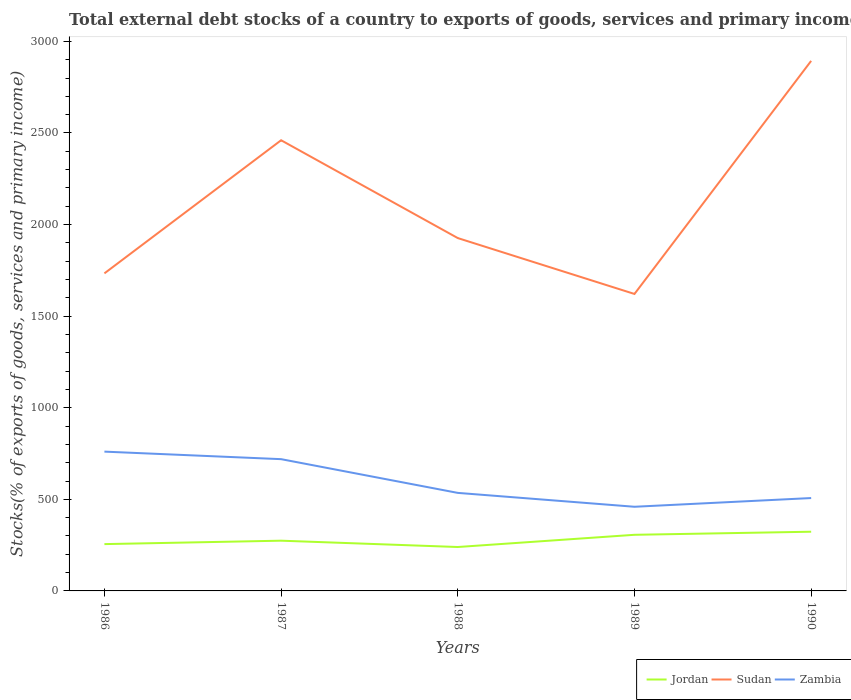Does the line corresponding to Zambia intersect with the line corresponding to Sudan?
Offer a very short reply. No. Is the number of lines equal to the number of legend labels?
Offer a very short reply. Yes. Across all years, what is the maximum total debt stocks in Sudan?
Make the answer very short. 1621.22. In which year was the total debt stocks in Zambia maximum?
Your answer should be very brief. 1989. What is the total total debt stocks in Zambia in the graph?
Your answer should be very brief. 41.12. What is the difference between the highest and the second highest total debt stocks in Zambia?
Your answer should be compact. 301.03. How many lines are there?
Your response must be concise. 3. What is the difference between two consecutive major ticks on the Y-axis?
Provide a short and direct response. 500. Are the values on the major ticks of Y-axis written in scientific E-notation?
Your response must be concise. No. Does the graph contain any zero values?
Offer a terse response. No. Does the graph contain grids?
Your answer should be very brief. No. How many legend labels are there?
Your answer should be very brief. 3. How are the legend labels stacked?
Offer a very short reply. Horizontal. What is the title of the graph?
Ensure brevity in your answer.  Total external debt stocks of a country to exports of goods, services and primary income. Does "Cayman Islands" appear as one of the legend labels in the graph?
Ensure brevity in your answer.  No. What is the label or title of the X-axis?
Ensure brevity in your answer.  Years. What is the label or title of the Y-axis?
Your answer should be very brief. Stocks(% of exports of goods, services and primary income). What is the Stocks(% of exports of goods, services and primary income) in Jordan in 1986?
Provide a short and direct response. 255.52. What is the Stocks(% of exports of goods, services and primary income) of Sudan in 1986?
Give a very brief answer. 1733.61. What is the Stocks(% of exports of goods, services and primary income) of Zambia in 1986?
Ensure brevity in your answer.  760.44. What is the Stocks(% of exports of goods, services and primary income) of Jordan in 1987?
Provide a succinct answer. 274.26. What is the Stocks(% of exports of goods, services and primary income) in Sudan in 1987?
Make the answer very short. 2460.33. What is the Stocks(% of exports of goods, services and primary income) of Zambia in 1987?
Offer a very short reply. 719.32. What is the Stocks(% of exports of goods, services and primary income) of Jordan in 1988?
Offer a terse response. 239.73. What is the Stocks(% of exports of goods, services and primary income) of Sudan in 1988?
Provide a succinct answer. 1926.25. What is the Stocks(% of exports of goods, services and primary income) of Zambia in 1988?
Make the answer very short. 535.19. What is the Stocks(% of exports of goods, services and primary income) in Jordan in 1989?
Give a very brief answer. 306.42. What is the Stocks(% of exports of goods, services and primary income) in Sudan in 1989?
Offer a very short reply. 1621.22. What is the Stocks(% of exports of goods, services and primary income) of Zambia in 1989?
Your answer should be compact. 459.41. What is the Stocks(% of exports of goods, services and primary income) of Jordan in 1990?
Keep it short and to the point. 323.17. What is the Stocks(% of exports of goods, services and primary income) in Sudan in 1990?
Ensure brevity in your answer.  2893.63. What is the Stocks(% of exports of goods, services and primary income) of Zambia in 1990?
Ensure brevity in your answer.  507. Across all years, what is the maximum Stocks(% of exports of goods, services and primary income) of Jordan?
Your answer should be compact. 323.17. Across all years, what is the maximum Stocks(% of exports of goods, services and primary income) of Sudan?
Your answer should be very brief. 2893.63. Across all years, what is the maximum Stocks(% of exports of goods, services and primary income) of Zambia?
Provide a succinct answer. 760.44. Across all years, what is the minimum Stocks(% of exports of goods, services and primary income) in Jordan?
Offer a terse response. 239.73. Across all years, what is the minimum Stocks(% of exports of goods, services and primary income) of Sudan?
Provide a succinct answer. 1621.22. Across all years, what is the minimum Stocks(% of exports of goods, services and primary income) in Zambia?
Your answer should be very brief. 459.41. What is the total Stocks(% of exports of goods, services and primary income) in Jordan in the graph?
Make the answer very short. 1399.09. What is the total Stocks(% of exports of goods, services and primary income) in Sudan in the graph?
Ensure brevity in your answer.  1.06e+04. What is the total Stocks(% of exports of goods, services and primary income) in Zambia in the graph?
Offer a very short reply. 2981.35. What is the difference between the Stocks(% of exports of goods, services and primary income) of Jordan in 1986 and that in 1987?
Ensure brevity in your answer.  -18.74. What is the difference between the Stocks(% of exports of goods, services and primary income) of Sudan in 1986 and that in 1987?
Provide a short and direct response. -726.73. What is the difference between the Stocks(% of exports of goods, services and primary income) in Zambia in 1986 and that in 1987?
Keep it short and to the point. 41.12. What is the difference between the Stocks(% of exports of goods, services and primary income) in Jordan in 1986 and that in 1988?
Offer a terse response. 15.79. What is the difference between the Stocks(% of exports of goods, services and primary income) in Sudan in 1986 and that in 1988?
Give a very brief answer. -192.65. What is the difference between the Stocks(% of exports of goods, services and primary income) of Zambia in 1986 and that in 1988?
Offer a very short reply. 225.25. What is the difference between the Stocks(% of exports of goods, services and primary income) of Jordan in 1986 and that in 1989?
Offer a very short reply. -50.9. What is the difference between the Stocks(% of exports of goods, services and primary income) in Sudan in 1986 and that in 1989?
Provide a short and direct response. 112.39. What is the difference between the Stocks(% of exports of goods, services and primary income) of Zambia in 1986 and that in 1989?
Make the answer very short. 301.03. What is the difference between the Stocks(% of exports of goods, services and primary income) in Jordan in 1986 and that in 1990?
Provide a succinct answer. -67.65. What is the difference between the Stocks(% of exports of goods, services and primary income) of Sudan in 1986 and that in 1990?
Your answer should be compact. -1160.03. What is the difference between the Stocks(% of exports of goods, services and primary income) of Zambia in 1986 and that in 1990?
Offer a terse response. 253.44. What is the difference between the Stocks(% of exports of goods, services and primary income) in Jordan in 1987 and that in 1988?
Make the answer very short. 34.53. What is the difference between the Stocks(% of exports of goods, services and primary income) in Sudan in 1987 and that in 1988?
Keep it short and to the point. 534.08. What is the difference between the Stocks(% of exports of goods, services and primary income) in Zambia in 1987 and that in 1988?
Make the answer very short. 184.13. What is the difference between the Stocks(% of exports of goods, services and primary income) in Jordan in 1987 and that in 1989?
Ensure brevity in your answer.  -32.16. What is the difference between the Stocks(% of exports of goods, services and primary income) in Sudan in 1987 and that in 1989?
Keep it short and to the point. 839.11. What is the difference between the Stocks(% of exports of goods, services and primary income) of Zambia in 1987 and that in 1989?
Your answer should be very brief. 259.91. What is the difference between the Stocks(% of exports of goods, services and primary income) of Jordan in 1987 and that in 1990?
Provide a short and direct response. -48.91. What is the difference between the Stocks(% of exports of goods, services and primary income) of Sudan in 1987 and that in 1990?
Offer a terse response. -433.3. What is the difference between the Stocks(% of exports of goods, services and primary income) in Zambia in 1987 and that in 1990?
Your answer should be very brief. 212.32. What is the difference between the Stocks(% of exports of goods, services and primary income) in Jordan in 1988 and that in 1989?
Your answer should be compact. -66.69. What is the difference between the Stocks(% of exports of goods, services and primary income) of Sudan in 1988 and that in 1989?
Offer a terse response. 305.04. What is the difference between the Stocks(% of exports of goods, services and primary income) in Zambia in 1988 and that in 1989?
Make the answer very short. 75.78. What is the difference between the Stocks(% of exports of goods, services and primary income) of Jordan in 1988 and that in 1990?
Keep it short and to the point. -83.44. What is the difference between the Stocks(% of exports of goods, services and primary income) in Sudan in 1988 and that in 1990?
Your answer should be compact. -967.38. What is the difference between the Stocks(% of exports of goods, services and primary income) in Zambia in 1988 and that in 1990?
Ensure brevity in your answer.  28.19. What is the difference between the Stocks(% of exports of goods, services and primary income) of Jordan in 1989 and that in 1990?
Provide a succinct answer. -16.75. What is the difference between the Stocks(% of exports of goods, services and primary income) in Sudan in 1989 and that in 1990?
Make the answer very short. -1272.42. What is the difference between the Stocks(% of exports of goods, services and primary income) of Zambia in 1989 and that in 1990?
Offer a terse response. -47.59. What is the difference between the Stocks(% of exports of goods, services and primary income) of Jordan in 1986 and the Stocks(% of exports of goods, services and primary income) of Sudan in 1987?
Give a very brief answer. -2204.81. What is the difference between the Stocks(% of exports of goods, services and primary income) of Jordan in 1986 and the Stocks(% of exports of goods, services and primary income) of Zambia in 1987?
Offer a terse response. -463.8. What is the difference between the Stocks(% of exports of goods, services and primary income) of Sudan in 1986 and the Stocks(% of exports of goods, services and primary income) of Zambia in 1987?
Offer a very short reply. 1014.29. What is the difference between the Stocks(% of exports of goods, services and primary income) of Jordan in 1986 and the Stocks(% of exports of goods, services and primary income) of Sudan in 1988?
Offer a terse response. -1670.73. What is the difference between the Stocks(% of exports of goods, services and primary income) of Jordan in 1986 and the Stocks(% of exports of goods, services and primary income) of Zambia in 1988?
Provide a succinct answer. -279.67. What is the difference between the Stocks(% of exports of goods, services and primary income) in Sudan in 1986 and the Stocks(% of exports of goods, services and primary income) in Zambia in 1988?
Your response must be concise. 1198.42. What is the difference between the Stocks(% of exports of goods, services and primary income) in Jordan in 1986 and the Stocks(% of exports of goods, services and primary income) in Sudan in 1989?
Make the answer very short. -1365.7. What is the difference between the Stocks(% of exports of goods, services and primary income) of Jordan in 1986 and the Stocks(% of exports of goods, services and primary income) of Zambia in 1989?
Keep it short and to the point. -203.89. What is the difference between the Stocks(% of exports of goods, services and primary income) of Sudan in 1986 and the Stocks(% of exports of goods, services and primary income) of Zambia in 1989?
Provide a succinct answer. 1274.2. What is the difference between the Stocks(% of exports of goods, services and primary income) in Jordan in 1986 and the Stocks(% of exports of goods, services and primary income) in Sudan in 1990?
Keep it short and to the point. -2638.12. What is the difference between the Stocks(% of exports of goods, services and primary income) of Jordan in 1986 and the Stocks(% of exports of goods, services and primary income) of Zambia in 1990?
Offer a very short reply. -251.48. What is the difference between the Stocks(% of exports of goods, services and primary income) in Sudan in 1986 and the Stocks(% of exports of goods, services and primary income) in Zambia in 1990?
Give a very brief answer. 1226.61. What is the difference between the Stocks(% of exports of goods, services and primary income) in Jordan in 1987 and the Stocks(% of exports of goods, services and primary income) in Sudan in 1988?
Your response must be concise. -1652. What is the difference between the Stocks(% of exports of goods, services and primary income) of Jordan in 1987 and the Stocks(% of exports of goods, services and primary income) of Zambia in 1988?
Give a very brief answer. -260.93. What is the difference between the Stocks(% of exports of goods, services and primary income) of Sudan in 1987 and the Stocks(% of exports of goods, services and primary income) of Zambia in 1988?
Offer a terse response. 1925.14. What is the difference between the Stocks(% of exports of goods, services and primary income) in Jordan in 1987 and the Stocks(% of exports of goods, services and primary income) in Sudan in 1989?
Your response must be concise. -1346.96. What is the difference between the Stocks(% of exports of goods, services and primary income) in Jordan in 1987 and the Stocks(% of exports of goods, services and primary income) in Zambia in 1989?
Offer a very short reply. -185.15. What is the difference between the Stocks(% of exports of goods, services and primary income) in Sudan in 1987 and the Stocks(% of exports of goods, services and primary income) in Zambia in 1989?
Give a very brief answer. 2000.92. What is the difference between the Stocks(% of exports of goods, services and primary income) in Jordan in 1987 and the Stocks(% of exports of goods, services and primary income) in Sudan in 1990?
Ensure brevity in your answer.  -2619.38. What is the difference between the Stocks(% of exports of goods, services and primary income) of Jordan in 1987 and the Stocks(% of exports of goods, services and primary income) of Zambia in 1990?
Offer a terse response. -232.74. What is the difference between the Stocks(% of exports of goods, services and primary income) of Sudan in 1987 and the Stocks(% of exports of goods, services and primary income) of Zambia in 1990?
Provide a short and direct response. 1953.33. What is the difference between the Stocks(% of exports of goods, services and primary income) in Jordan in 1988 and the Stocks(% of exports of goods, services and primary income) in Sudan in 1989?
Ensure brevity in your answer.  -1381.49. What is the difference between the Stocks(% of exports of goods, services and primary income) of Jordan in 1988 and the Stocks(% of exports of goods, services and primary income) of Zambia in 1989?
Make the answer very short. -219.68. What is the difference between the Stocks(% of exports of goods, services and primary income) of Sudan in 1988 and the Stocks(% of exports of goods, services and primary income) of Zambia in 1989?
Ensure brevity in your answer.  1466.85. What is the difference between the Stocks(% of exports of goods, services and primary income) of Jordan in 1988 and the Stocks(% of exports of goods, services and primary income) of Sudan in 1990?
Offer a terse response. -2653.9. What is the difference between the Stocks(% of exports of goods, services and primary income) of Jordan in 1988 and the Stocks(% of exports of goods, services and primary income) of Zambia in 1990?
Your answer should be compact. -267.27. What is the difference between the Stocks(% of exports of goods, services and primary income) of Sudan in 1988 and the Stocks(% of exports of goods, services and primary income) of Zambia in 1990?
Provide a succinct answer. 1419.25. What is the difference between the Stocks(% of exports of goods, services and primary income) in Jordan in 1989 and the Stocks(% of exports of goods, services and primary income) in Sudan in 1990?
Keep it short and to the point. -2587.22. What is the difference between the Stocks(% of exports of goods, services and primary income) of Jordan in 1989 and the Stocks(% of exports of goods, services and primary income) of Zambia in 1990?
Your answer should be compact. -200.58. What is the difference between the Stocks(% of exports of goods, services and primary income) in Sudan in 1989 and the Stocks(% of exports of goods, services and primary income) in Zambia in 1990?
Keep it short and to the point. 1114.22. What is the average Stocks(% of exports of goods, services and primary income) in Jordan per year?
Your answer should be compact. 279.82. What is the average Stocks(% of exports of goods, services and primary income) of Sudan per year?
Your answer should be compact. 2127.01. What is the average Stocks(% of exports of goods, services and primary income) in Zambia per year?
Offer a very short reply. 596.27. In the year 1986, what is the difference between the Stocks(% of exports of goods, services and primary income) in Jordan and Stocks(% of exports of goods, services and primary income) in Sudan?
Your response must be concise. -1478.09. In the year 1986, what is the difference between the Stocks(% of exports of goods, services and primary income) of Jordan and Stocks(% of exports of goods, services and primary income) of Zambia?
Keep it short and to the point. -504.92. In the year 1986, what is the difference between the Stocks(% of exports of goods, services and primary income) in Sudan and Stocks(% of exports of goods, services and primary income) in Zambia?
Your response must be concise. 973.17. In the year 1987, what is the difference between the Stocks(% of exports of goods, services and primary income) in Jordan and Stocks(% of exports of goods, services and primary income) in Sudan?
Keep it short and to the point. -2186.07. In the year 1987, what is the difference between the Stocks(% of exports of goods, services and primary income) of Jordan and Stocks(% of exports of goods, services and primary income) of Zambia?
Offer a very short reply. -445.06. In the year 1987, what is the difference between the Stocks(% of exports of goods, services and primary income) of Sudan and Stocks(% of exports of goods, services and primary income) of Zambia?
Offer a terse response. 1741.01. In the year 1988, what is the difference between the Stocks(% of exports of goods, services and primary income) in Jordan and Stocks(% of exports of goods, services and primary income) in Sudan?
Your response must be concise. -1686.52. In the year 1988, what is the difference between the Stocks(% of exports of goods, services and primary income) of Jordan and Stocks(% of exports of goods, services and primary income) of Zambia?
Your answer should be compact. -295.46. In the year 1988, what is the difference between the Stocks(% of exports of goods, services and primary income) of Sudan and Stocks(% of exports of goods, services and primary income) of Zambia?
Your answer should be compact. 1391.06. In the year 1989, what is the difference between the Stocks(% of exports of goods, services and primary income) in Jordan and Stocks(% of exports of goods, services and primary income) in Sudan?
Offer a very short reply. -1314.8. In the year 1989, what is the difference between the Stocks(% of exports of goods, services and primary income) in Jordan and Stocks(% of exports of goods, services and primary income) in Zambia?
Offer a terse response. -152.99. In the year 1989, what is the difference between the Stocks(% of exports of goods, services and primary income) in Sudan and Stocks(% of exports of goods, services and primary income) in Zambia?
Offer a terse response. 1161.81. In the year 1990, what is the difference between the Stocks(% of exports of goods, services and primary income) in Jordan and Stocks(% of exports of goods, services and primary income) in Sudan?
Keep it short and to the point. -2570.47. In the year 1990, what is the difference between the Stocks(% of exports of goods, services and primary income) in Jordan and Stocks(% of exports of goods, services and primary income) in Zambia?
Provide a short and direct response. -183.83. In the year 1990, what is the difference between the Stocks(% of exports of goods, services and primary income) of Sudan and Stocks(% of exports of goods, services and primary income) of Zambia?
Offer a terse response. 2386.64. What is the ratio of the Stocks(% of exports of goods, services and primary income) of Jordan in 1986 to that in 1987?
Give a very brief answer. 0.93. What is the ratio of the Stocks(% of exports of goods, services and primary income) of Sudan in 1986 to that in 1987?
Your answer should be compact. 0.7. What is the ratio of the Stocks(% of exports of goods, services and primary income) in Zambia in 1986 to that in 1987?
Offer a terse response. 1.06. What is the ratio of the Stocks(% of exports of goods, services and primary income) in Jordan in 1986 to that in 1988?
Keep it short and to the point. 1.07. What is the ratio of the Stocks(% of exports of goods, services and primary income) of Zambia in 1986 to that in 1988?
Give a very brief answer. 1.42. What is the ratio of the Stocks(% of exports of goods, services and primary income) in Jordan in 1986 to that in 1989?
Make the answer very short. 0.83. What is the ratio of the Stocks(% of exports of goods, services and primary income) in Sudan in 1986 to that in 1989?
Provide a short and direct response. 1.07. What is the ratio of the Stocks(% of exports of goods, services and primary income) of Zambia in 1986 to that in 1989?
Provide a succinct answer. 1.66. What is the ratio of the Stocks(% of exports of goods, services and primary income) of Jordan in 1986 to that in 1990?
Provide a short and direct response. 0.79. What is the ratio of the Stocks(% of exports of goods, services and primary income) in Sudan in 1986 to that in 1990?
Give a very brief answer. 0.6. What is the ratio of the Stocks(% of exports of goods, services and primary income) of Zambia in 1986 to that in 1990?
Your response must be concise. 1.5. What is the ratio of the Stocks(% of exports of goods, services and primary income) in Jordan in 1987 to that in 1988?
Give a very brief answer. 1.14. What is the ratio of the Stocks(% of exports of goods, services and primary income) in Sudan in 1987 to that in 1988?
Provide a succinct answer. 1.28. What is the ratio of the Stocks(% of exports of goods, services and primary income) in Zambia in 1987 to that in 1988?
Offer a very short reply. 1.34. What is the ratio of the Stocks(% of exports of goods, services and primary income) in Jordan in 1987 to that in 1989?
Your response must be concise. 0.9. What is the ratio of the Stocks(% of exports of goods, services and primary income) of Sudan in 1987 to that in 1989?
Ensure brevity in your answer.  1.52. What is the ratio of the Stocks(% of exports of goods, services and primary income) in Zambia in 1987 to that in 1989?
Ensure brevity in your answer.  1.57. What is the ratio of the Stocks(% of exports of goods, services and primary income) of Jordan in 1987 to that in 1990?
Ensure brevity in your answer.  0.85. What is the ratio of the Stocks(% of exports of goods, services and primary income) of Sudan in 1987 to that in 1990?
Your answer should be compact. 0.85. What is the ratio of the Stocks(% of exports of goods, services and primary income) of Zambia in 1987 to that in 1990?
Your answer should be very brief. 1.42. What is the ratio of the Stocks(% of exports of goods, services and primary income) in Jordan in 1988 to that in 1989?
Provide a succinct answer. 0.78. What is the ratio of the Stocks(% of exports of goods, services and primary income) of Sudan in 1988 to that in 1989?
Make the answer very short. 1.19. What is the ratio of the Stocks(% of exports of goods, services and primary income) in Zambia in 1988 to that in 1989?
Make the answer very short. 1.17. What is the ratio of the Stocks(% of exports of goods, services and primary income) of Jordan in 1988 to that in 1990?
Your answer should be compact. 0.74. What is the ratio of the Stocks(% of exports of goods, services and primary income) in Sudan in 1988 to that in 1990?
Provide a succinct answer. 0.67. What is the ratio of the Stocks(% of exports of goods, services and primary income) of Zambia in 1988 to that in 1990?
Offer a very short reply. 1.06. What is the ratio of the Stocks(% of exports of goods, services and primary income) in Jordan in 1989 to that in 1990?
Your response must be concise. 0.95. What is the ratio of the Stocks(% of exports of goods, services and primary income) in Sudan in 1989 to that in 1990?
Provide a succinct answer. 0.56. What is the ratio of the Stocks(% of exports of goods, services and primary income) in Zambia in 1989 to that in 1990?
Make the answer very short. 0.91. What is the difference between the highest and the second highest Stocks(% of exports of goods, services and primary income) of Jordan?
Keep it short and to the point. 16.75. What is the difference between the highest and the second highest Stocks(% of exports of goods, services and primary income) in Sudan?
Give a very brief answer. 433.3. What is the difference between the highest and the second highest Stocks(% of exports of goods, services and primary income) in Zambia?
Make the answer very short. 41.12. What is the difference between the highest and the lowest Stocks(% of exports of goods, services and primary income) of Jordan?
Give a very brief answer. 83.44. What is the difference between the highest and the lowest Stocks(% of exports of goods, services and primary income) of Sudan?
Ensure brevity in your answer.  1272.42. What is the difference between the highest and the lowest Stocks(% of exports of goods, services and primary income) of Zambia?
Your response must be concise. 301.03. 